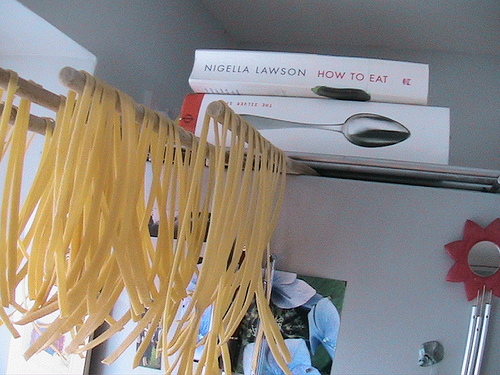<image>
Is the noodles under the book? Yes. The noodles is positioned underneath the book, with the book above it in the vertical space. Is there a pasta under the rod? Yes. The pasta is positioned underneath the rod, with the rod above it in the vertical space. 